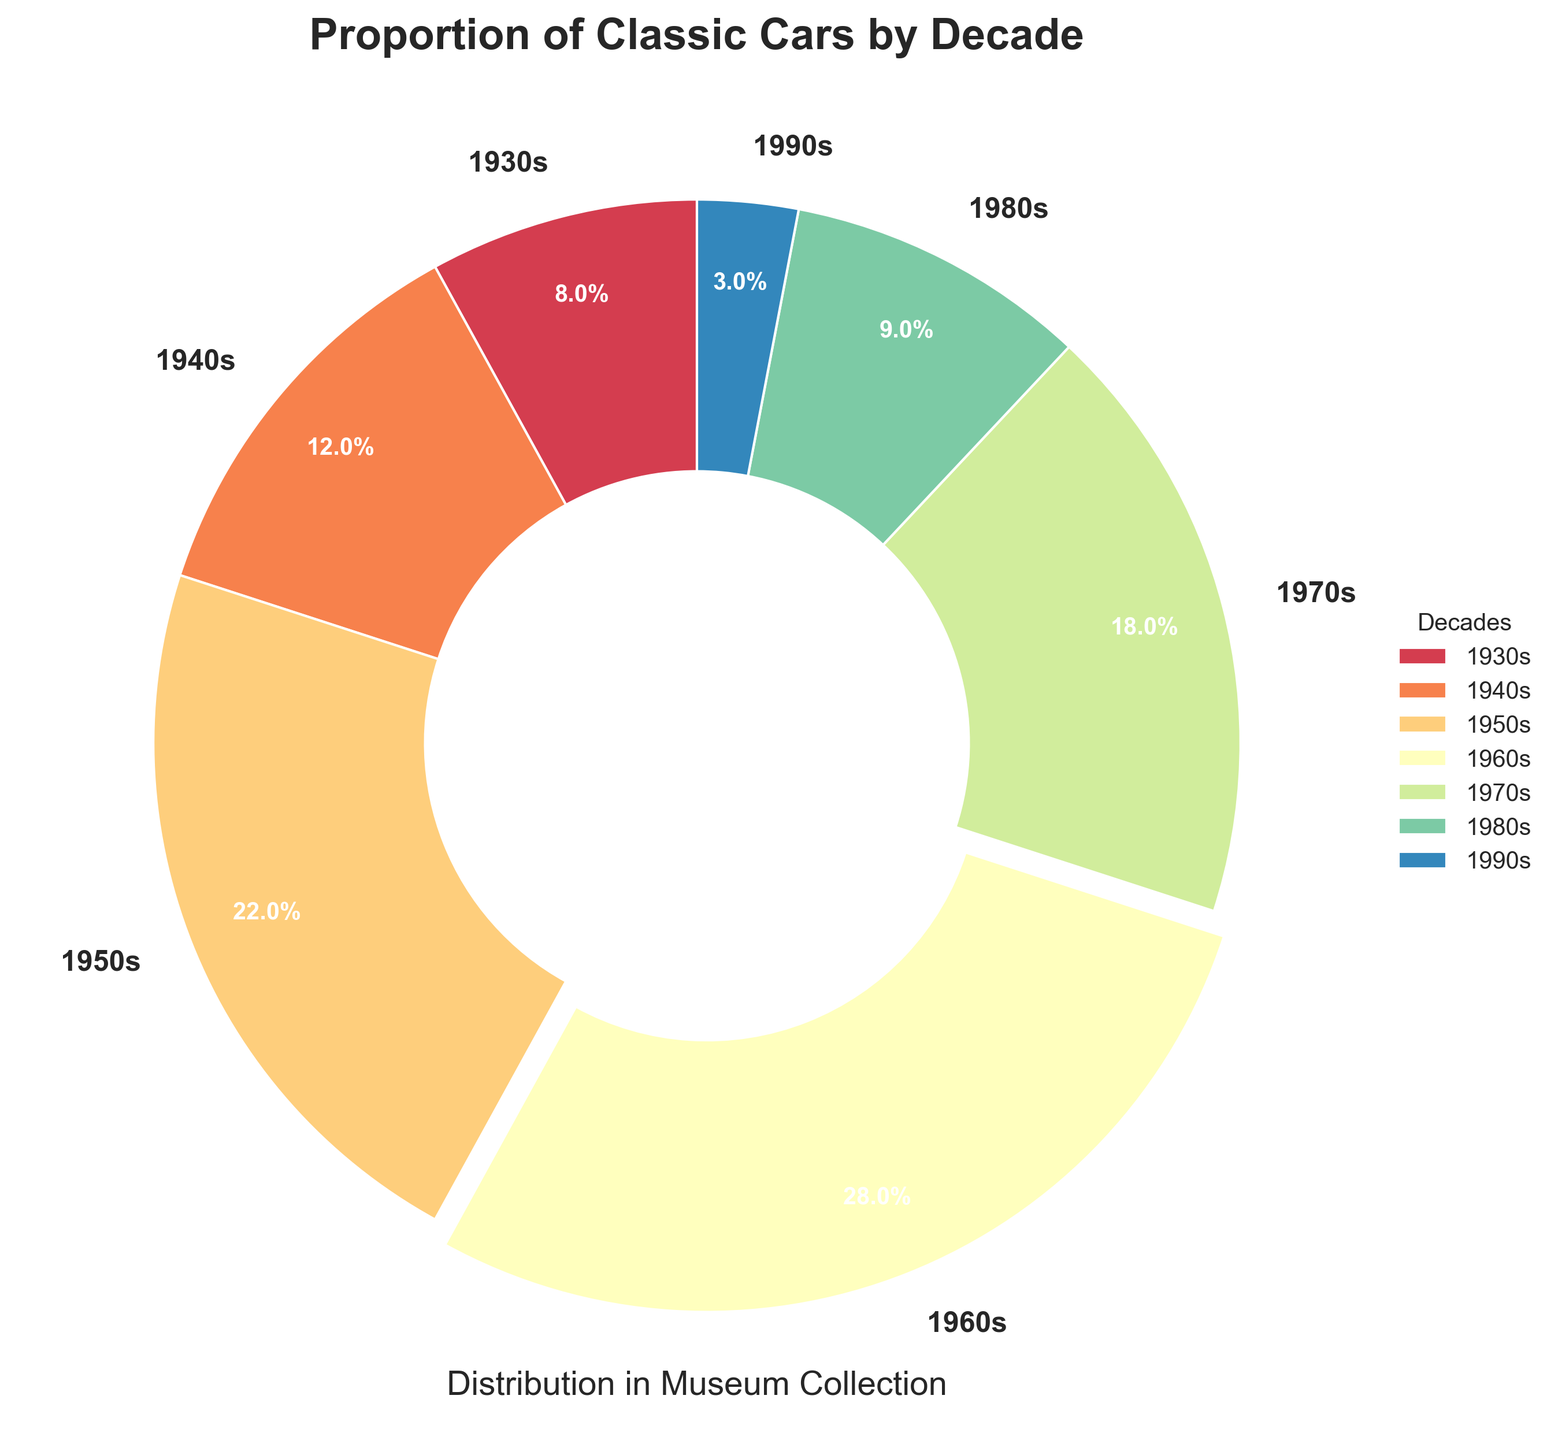What's the most represented decade in the classic car collection? The pie chart segments indicate the percentage of cars from each decade. The 1960s segment is the largest at 28%, which means it is the most represented decade.
Answer: 1960s Which decade has the least representation? The percentages in the pie chart show that the 1990s have the smallest segment with 3%, indicating the least representation.
Answer: 1990s What's the total percentage of cars from the 1930s and 1940s combined? To find the combined percentage, sum the percentages from the 1930s (8%) and 1940s (12%). So, 8% + 12% = 20%.
Answer: 20% How does the proportion of cars from the 1970s compare to the 1980s? The pie chart shows that the 1970s have 18%, while the 1980s have 9%. Thus, the 1970s have a higher proportion.
Answer: 1970s have a higher proportion What's the difference in percentage between the most and least represented decades? The most represented decade (1960s) has 28%, and the least represented decade (1990s) has 3%. The difference is 28% - 3% = 25%.
Answer: 25% For decades with over 20% representation, what is their combined total percentage? The decades with over 20% representation are 1950s (22%) and 1960s (28%). Sum their percentages: 22% + 28% = 50%.
Answer: 50% What's the combined percentage of cars from the decades prior to the 1950s? The relevant decades are the 1930s (8%) and 1940s (12%). Sum their percentages: 8% + 12% = 20%.
Answer: 20% What visual attribute distinguishes the most represented decade on the pie chart? The most represented decade (1960s with 28%) has a slightly separated or 'exploded' slice from the rest of the pie chart, making it visually distinct.
Answer: Its slice is slightly separated Which two decades have the closest proportion of classic cars? Comparing the percentages, the 1940s (12%) and 1980s (9%) are close, but the 1930s (8%) and 1980s (9%) are closer with only a 1% difference.
Answer: 1930s and 1980s If you combine the three decades with the least representation, what is the total percentage? The least represented decades are the 1990s (3%), 1930s (8%), and 1980s (9%). Sum their percentages: 3% + 8% + 9% = 20%.
Answer: 20% 